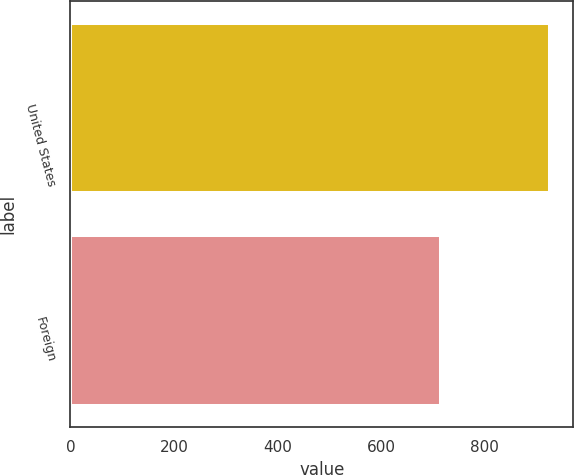<chart> <loc_0><loc_0><loc_500><loc_500><bar_chart><fcel>United States<fcel>Foreign<nl><fcel>925<fcel>715<nl></chart> 